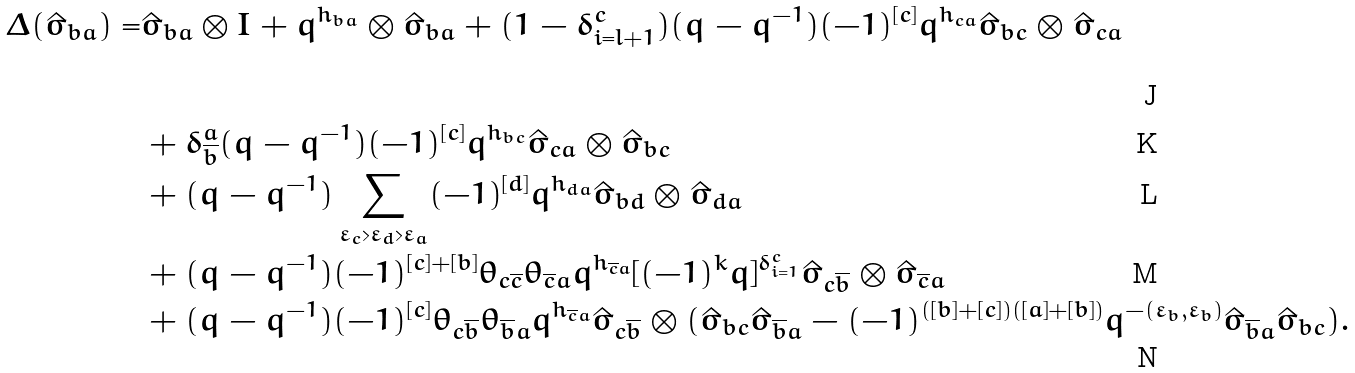<formula> <loc_0><loc_0><loc_500><loc_500>\Delta ( \hat { \sigma } _ { b a } ) = & \hat { \sigma } _ { b a } \otimes I + q ^ { h _ { b a } } \otimes \hat { \sigma } _ { b a } + ( 1 - \delta ^ { c } _ { i = l + 1 } ) ( q - q ^ { - 1 } ) ( - 1 ) ^ { [ c ] } q ^ { h _ { c a } } \hat { \sigma } _ { b c } \otimes \hat { \sigma } _ { c a } \\ & + \delta ^ { a } _ { \overline { b } } ( q - q ^ { - 1 } ) ( - 1 ) ^ { [ c ] } q ^ { h _ { b c } } \hat { \sigma } _ { c a } \otimes \hat { \sigma } _ { b c } \\ & + ( q - q ^ { - 1 } ) \sum _ { \varepsilon _ { c } > \varepsilon _ { d } > \varepsilon _ { a } } ( - 1 ) ^ { [ d ] } q ^ { h _ { d a } } \hat { \sigma } _ { b d } \otimes \hat { \sigma } _ { d a } \\ & + ( q - q ^ { - 1 } ) ( - 1 ) ^ { [ c ] + [ b ] } \theta _ { c \overline { c } } \theta _ { \overline { c } a } q ^ { h _ { \overline { c } a } } [ ( - 1 ) ^ { k } q ] ^ { \delta ^ { c } _ { i = 1 } } \hat { \sigma } _ { c \overline { b } } \otimes \hat { \sigma } _ { \overline { c } a } \\ & + ( q - q ^ { - 1 } ) ( - 1 ) ^ { [ c ] } \theta _ { c \overline { b } } \theta _ { \overline { b } a } q ^ { h _ { \overline { c } a } } \hat { \sigma } _ { c \overline { b } } \otimes ( \hat { \sigma } _ { b c } \hat { \sigma } _ { \overline { b } a } - ( - 1 ) ^ { ( [ b ] + [ c ] ) ( [ a ] + [ b ] ) } q ^ { - ( \varepsilon _ { b } , \varepsilon _ { b } ) } \hat { \sigma } _ { \overline { b } a } \hat { \sigma } _ { b c } ) .</formula> 